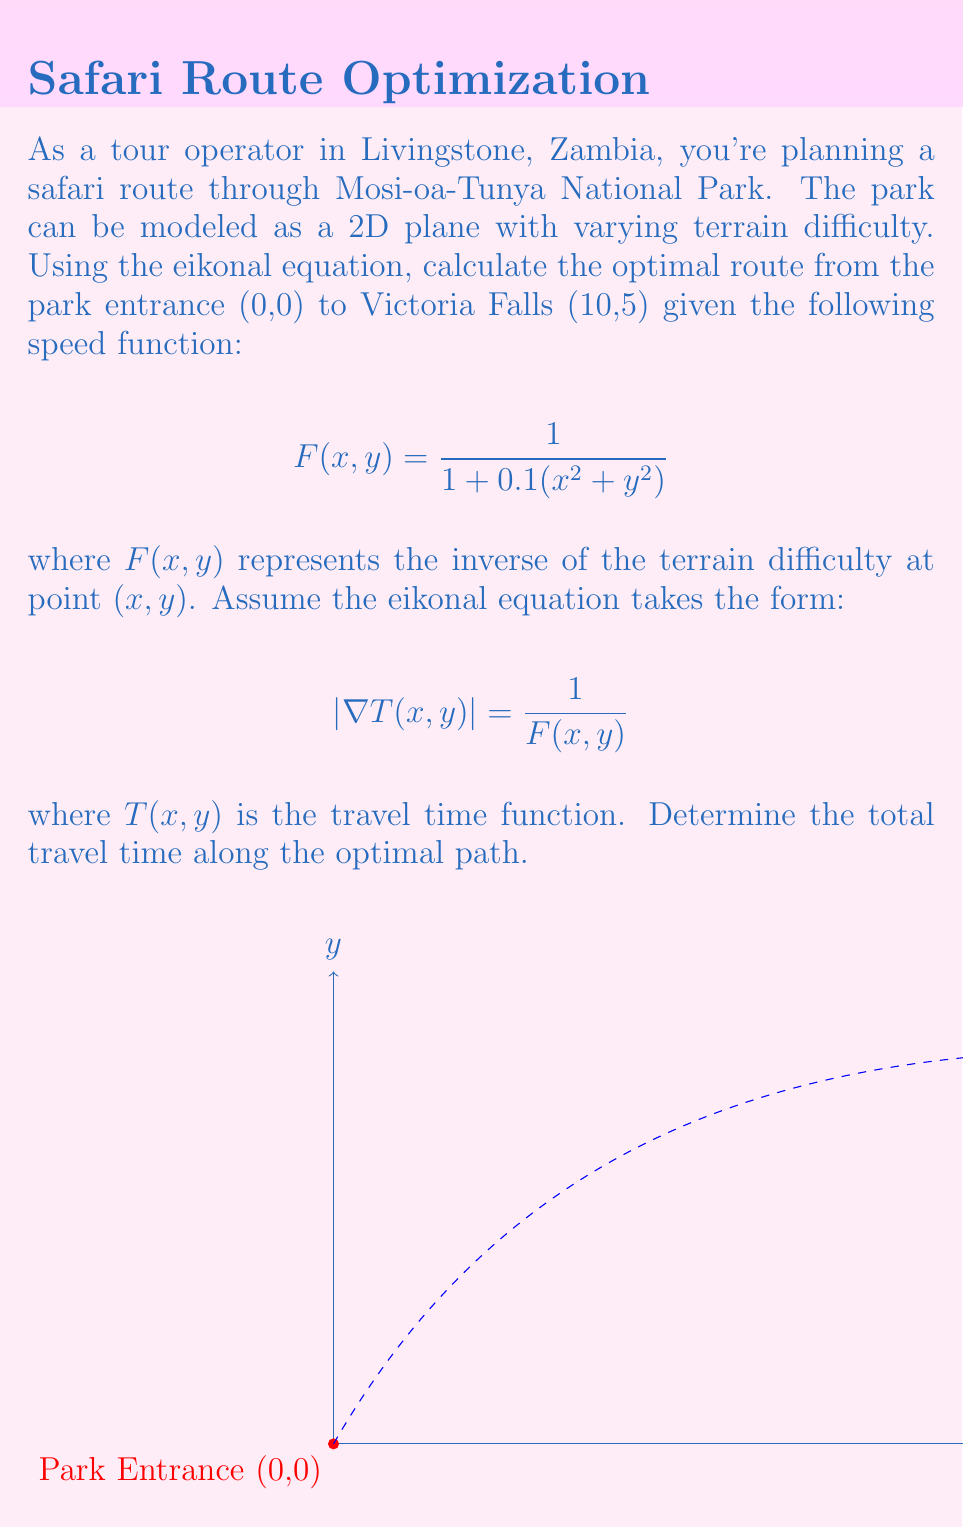Give your solution to this math problem. To solve this problem, we'll follow these steps:

1) The eikonal equation describes the propagation of a wavefront in a medium with varying speed. In our case, it represents the optimal travel time from the starting point to any other point in the park.

2) Given the eikonal equation:

   $$|\nabla T(x,y)| = \frac{1}{F(x,y)} = 1 + 0.1(x^2 + y^2)$$

3) To find the optimal path, we need to solve this partial differential equation. However, an analytical solution is complex for this specific speed function. In practice, we would use numerical methods like the Fast Marching Method.

4) For this simplified example, we'll approximate the solution by assuming the optimal path is close to a straight line between the start and end points. This is a reasonable assumption given the relatively simple speed function.

5) The straight-line path can be parameterized as:

   $$x(t) = 10t, y(t) = 5t, \text{ for } 0 \leq t \leq 1$$

6) The travel time along this path can be calculated by integrating the inverse of the speed function:

   $$\text{Travel Time} = \int_0^1 \frac{1}{F(x(t),y(t))} \sqrt{\left(\frac{dx}{dt}\right)^2 + \left(\frac{dy}{dt}\right)^2} dt$$

7) Substituting our functions:

   $$\text{Travel Time} = \int_0^1 [1 + 0.1((10t)^2 + (5t)^2)] \sqrt{10^2 + 5^2} dt$$

8) Simplifying:

   $$\text{Travel Time} = \sqrt{125} \int_0^1 (1 + 12.5t^2) dt$$

9) Evaluating the integral:

   $$\text{Travel Time} = \sqrt{125} [t + \frac{12.5}{3}t^3]_0^1 = \sqrt{125} (1 + \frac{12.5}{3}) \approx 19.84$$

This approximation gives us an estimate of the optimal travel time.
Answer: Approximately 19.84 time units 